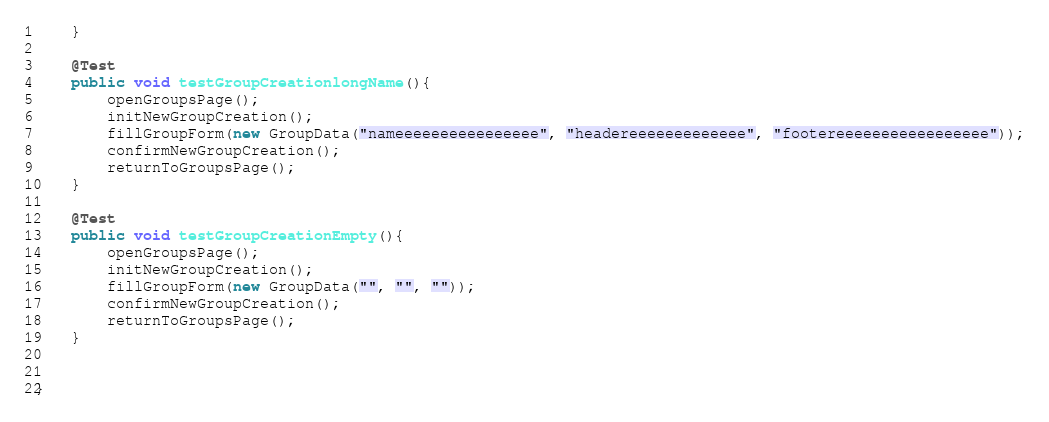<code> <loc_0><loc_0><loc_500><loc_500><_Java_>    }

    @Test
    public void testGroupCreationlongName(){
        openGroupsPage();
        initNewGroupCreation();
        fillGroupForm(new GroupData("nameeeeeeeeeeeeeeee", "headereeeeeeeeeeeee", "footereeeeeeeeeeeeeeeee"));
        confirmNewGroupCreation();
        returnToGroupsPage();
    }

    @Test
    public void testGroupCreationEmpty(){
        openGroupsPage();
        initNewGroupCreation();
        fillGroupForm(new GroupData("", "", ""));
        confirmNewGroupCreation();
        returnToGroupsPage();
    }


}
</code> 